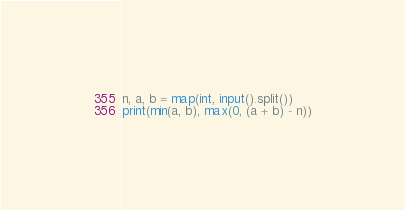Convert code to text. <code><loc_0><loc_0><loc_500><loc_500><_Python_>n, a, b = map(int, input().split())
print(min(a, b), max(0, (a + b) - n))</code> 